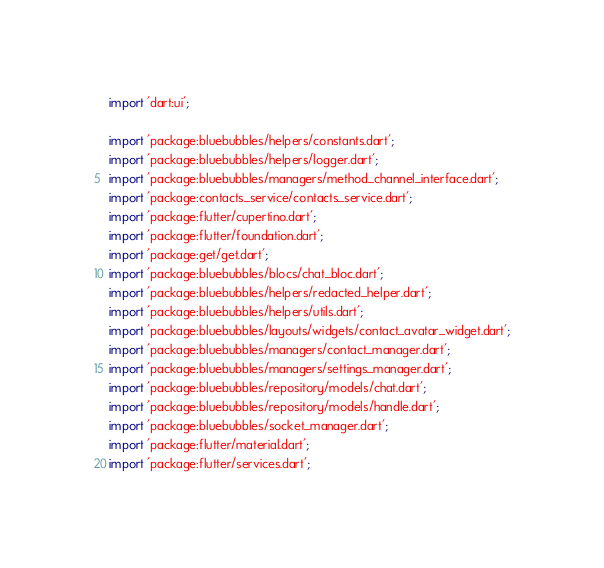Convert code to text. <code><loc_0><loc_0><loc_500><loc_500><_Dart_>import 'dart:ui';

import 'package:bluebubbles/helpers/constants.dart';
import 'package:bluebubbles/helpers/logger.dart';
import 'package:bluebubbles/managers/method_channel_interface.dart';
import 'package:contacts_service/contacts_service.dart';
import 'package:flutter/cupertino.dart';
import 'package:flutter/foundation.dart';
import 'package:get/get.dart';
import 'package:bluebubbles/blocs/chat_bloc.dart';
import 'package:bluebubbles/helpers/redacted_helper.dart';
import 'package:bluebubbles/helpers/utils.dart';
import 'package:bluebubbles/layouts/widgets/contact_avatar_widget.dart';
import 'package:bluebubbles/managers/contact_manager.dart';
import 'package:bluebubbles/managers/settings_manager.dart';
import 'package:bluebubbles/repository/models/chat.dart';
import 'package:bluebubbles/repository/models/handle.dart';
import 'package:bluebubbles/socket_manager.dart';
import 'package:flutter/material.dart';
import 'package:flutter/services.dart';</code> 